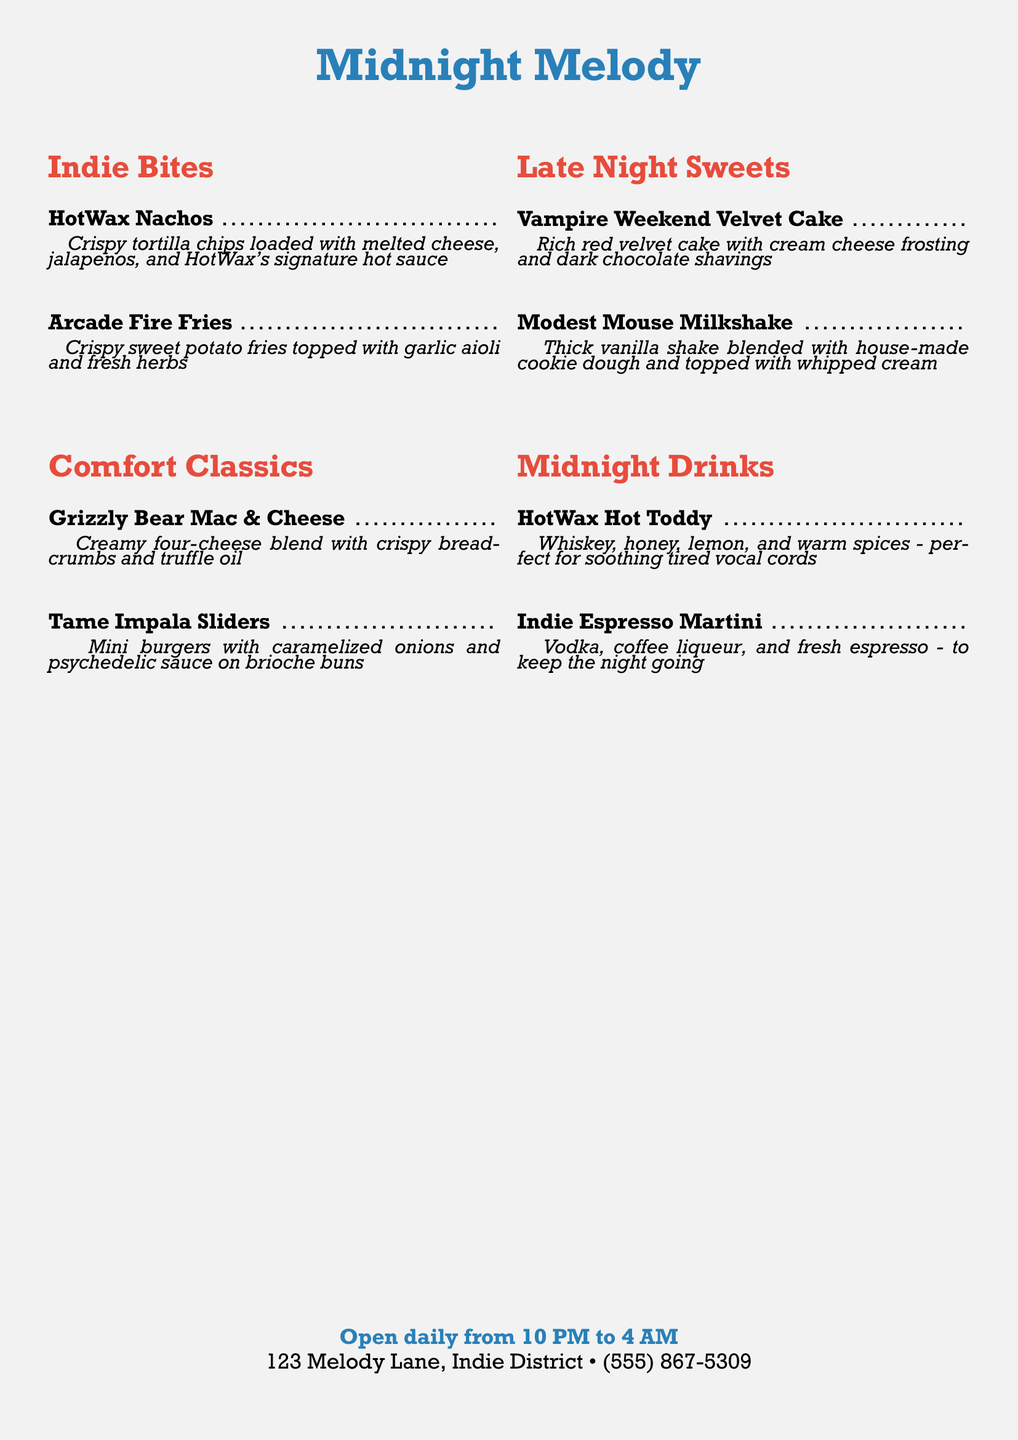What are the opening hours? The opening hours are specified in the menu, showing when the restaurant operates.
Answer: Open daily from 10 PM to 4 AM What is the address of the restaurant? The address is listed at the bottom of the menu, indicating where it is located.
Answer: 123 Melody Lane, Indie District What is the signature sauce on the HotWax Nachos? The menu describes the HotWax Nachos and mentions a specific sauce that is signature to the restaurant.
Answer: HotWax's signature hot sauce What type of cake is offered as a late-night sweet? The dessert section lists the type of cake available, which is important for customers looking for sweets.
Answer: Velvet Cake What drink is recommended for soothing tired vocal cords? The menu specifies a drink that is particularly suited for soothing vocal cords after a concert.
Answer: HotWax Hot Toddy How many mini burgers come with the Tame Impala Sliders? The item's description suggests it is served in a specific quantity, indicating the portion size.
Answer: Mini burgers What type of fries are featured on the menu? The menu highlights a specific type of fries, providing options for customers who may prefer something different.
Answer: Sweet potato fries What is included in the Grizzly Bear Mac & Cheese? The description mentions specific ingredients that create this comforting dish, essential for understanding its flavor profile.
Answer: Four-cheese blend What two main alcohol ingredients make up the Indie Espresso Martini? The drink section lists components of the Indie Espresso Martini, which are crucial for customers interested in cocktail options.
Answer: Vodka, coffee liqueur 